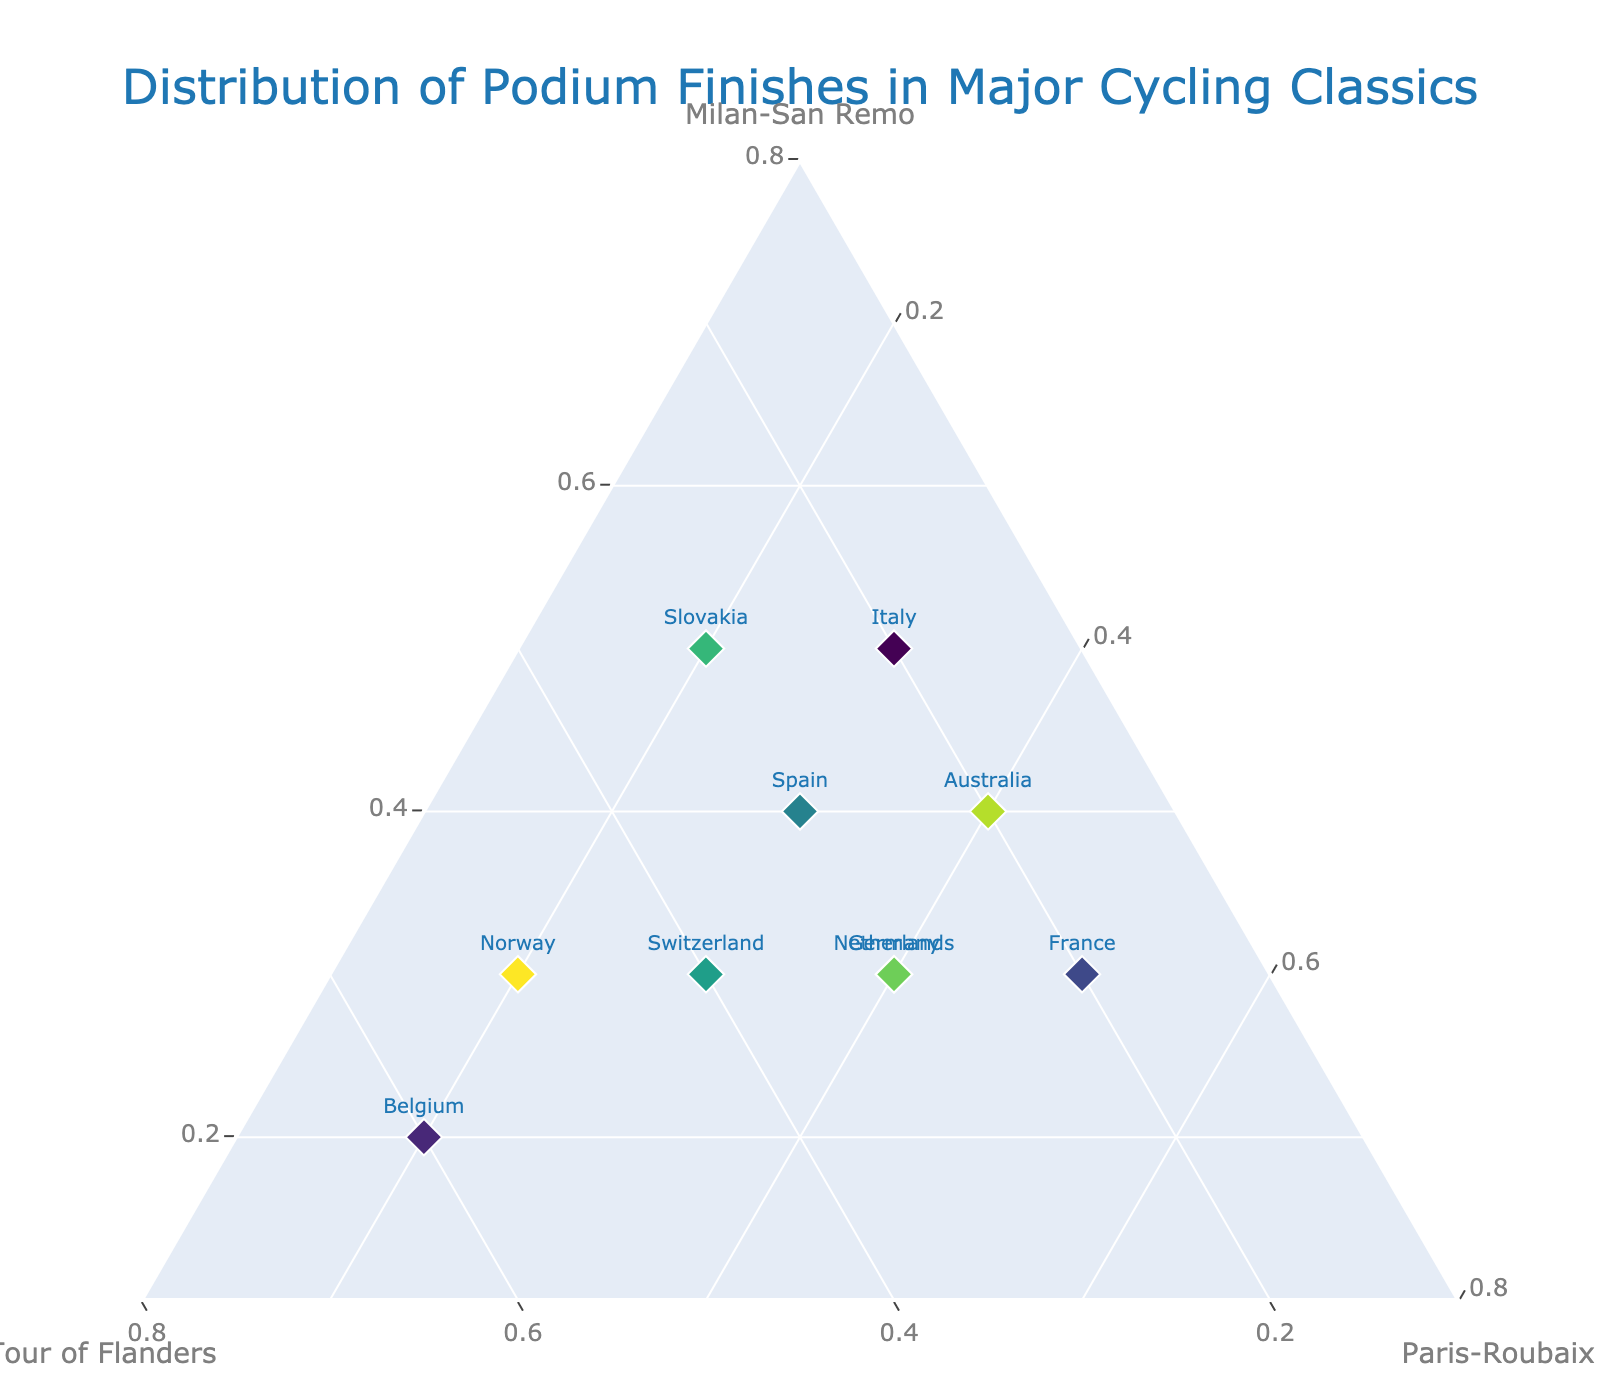What is the title of the ternary plot? The title is located at the top center of the plot and states the main subject of the visualization.
Answer: Distribution of Podium Finishes in Major Cycling Classics How many countries are displayed in the ternary plot? The number of distinct data points, represented by markers, indicates the total number of countries plotted. By counting these markers, we can determine the number of countries.
Answer: 10 Which country has the highest proportion of podium finishes in the Tour of Flanders? The b-axis is labeled "Tour of Flanders." By identifying the country that is closest to the b-axis apex (top of the plot), we can find the country with the highest proportion of podium finishes.
Answer: Belgium Which country has an equal proportion of podium finishes in Milan-San Remo and Paris-Roubaix? By visually inspecting for markers where the values for Milan-San Remo (a-axis) and Paris-Roubaix (c-axis) appear to be equal, we can identify the country in question.
Answer: Spain Which axis does the Norwegian marker approach the most closely? By visually locating the position of Norway's marker and noting which labeled axis it is closest to, we can determine which classic has the highest proportion for Norway.
Answer: Tour of Flanders Which country has the most balanced distribution of podium finishes across all three classics? We look for the marker that is closest to the center of the ternary plot, indicating a nearly equal distribution among Milan-San Remo, Tour of Flanders, and Paris-Roubaix.
Answer: Netherlands Which country has its least podium finishes in Milan-San Remo? We need to identify the position for each country on the a-axis and find the country with the lowest value, indicating the least podium finishes in Milan-San Remo.
Answer: Belgium What is the combined proportion of podium finishes in Milan-San Remo and Paris-Roubaix for Switzerland? Add the proportions of Milan-San Remo (a-axis) and Paris-Roubaix (c-axis) for Switzerland to get the combined value. Switzerland has values of 0.3 (Milan-San Remo) and 0.3 (Paris-Roubaix).
Answer: 0.6 Which two countries have identical proportions for all three classics? By carefully checking the proportions of Milan-San Remo, Tour of Flanders, and Paris-Roubaix for each country, we can identify any two countries that have identical values across all three categories.
Answer: None 